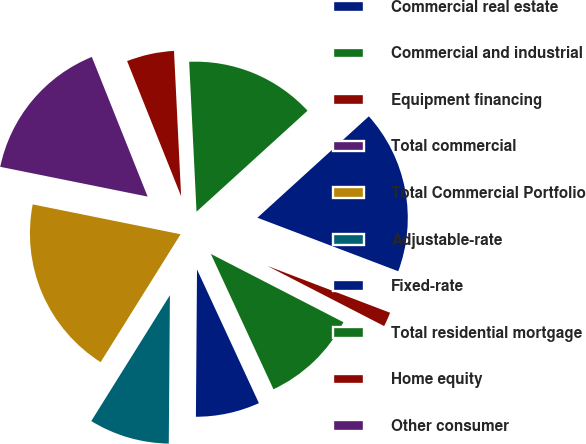Convert chart to OTSL. <chart><loc_0><loc_0><loc_500><loc_500><pie_chart><fcel>Commercial real estate<fcel>Commercial and industrial<fcel>Equipment financing<fcel>Total commercial<fcel>Total Commercial Portfolio<fcel>Adjustable-rate<fcel>Fixed-rate<fcel>Total residential mortgage<fcel>Home equity<fcel>Other consumer<nl><fcel>17.53%<fcel>14.03%<fcel>5.27%<fcel>15.78%<fcel>19.28%<fcel>8.77%<fcel>7.02%<fcel>10.53%<fcel>1.77%<fcel>0.02%<nl></chart> 